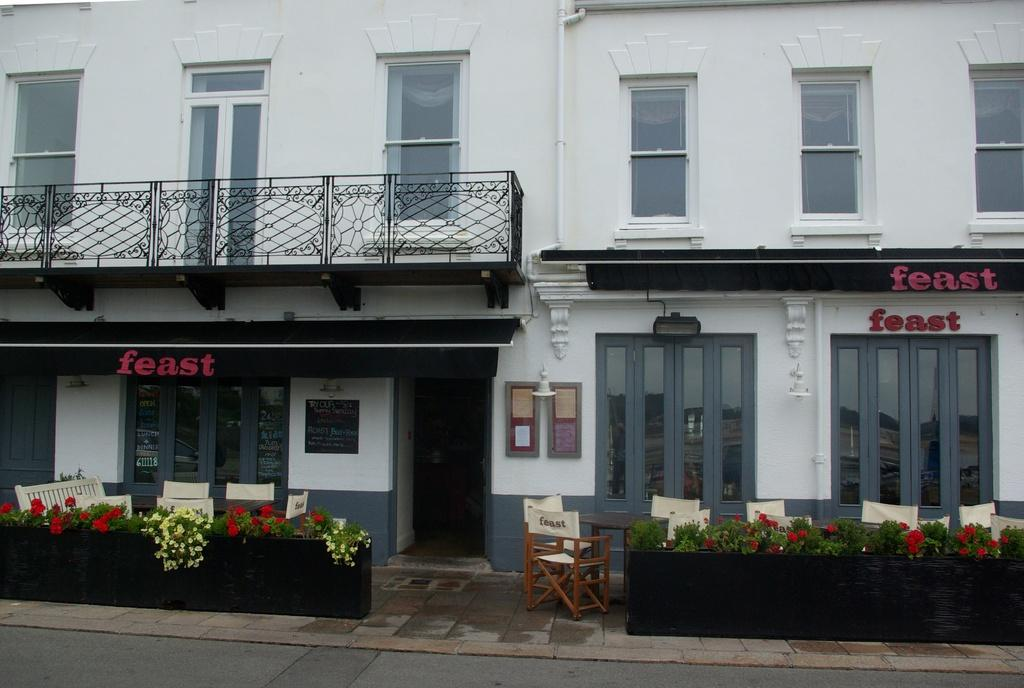What type of structure is in the image? There is a building in the image. What can be used for cooking in the image? Grills are present in the image. What allows light to enter the building in the image? There are windows in the image. How can someone enter the building in the image? There is a door in the image. What is used for displaying information in the image? A board is visible in the image. What provides illumination in the image? Lights are present in the image. What can be used for eating or working on in the image? There is a table in the image. What can be used for sitting in the image? Chairs are visible in the image. What type of natural decoration is present in the image? Flowers are present in the image. What type of vegetation is visible in the image? Leaves are visible in the image. What is at the bottom of the image? At the bottom of the image, there is a road. How many ears of corn are visible on the table in the image? There is no corn present on the table in the image. Can you describe the person walking down the road at the bottom of the image? There is no person visible in the image; only a road is present at the bottom. What type of celestial object can be seen shining in the sky in the image? There is no star visible in the sky in the image. 